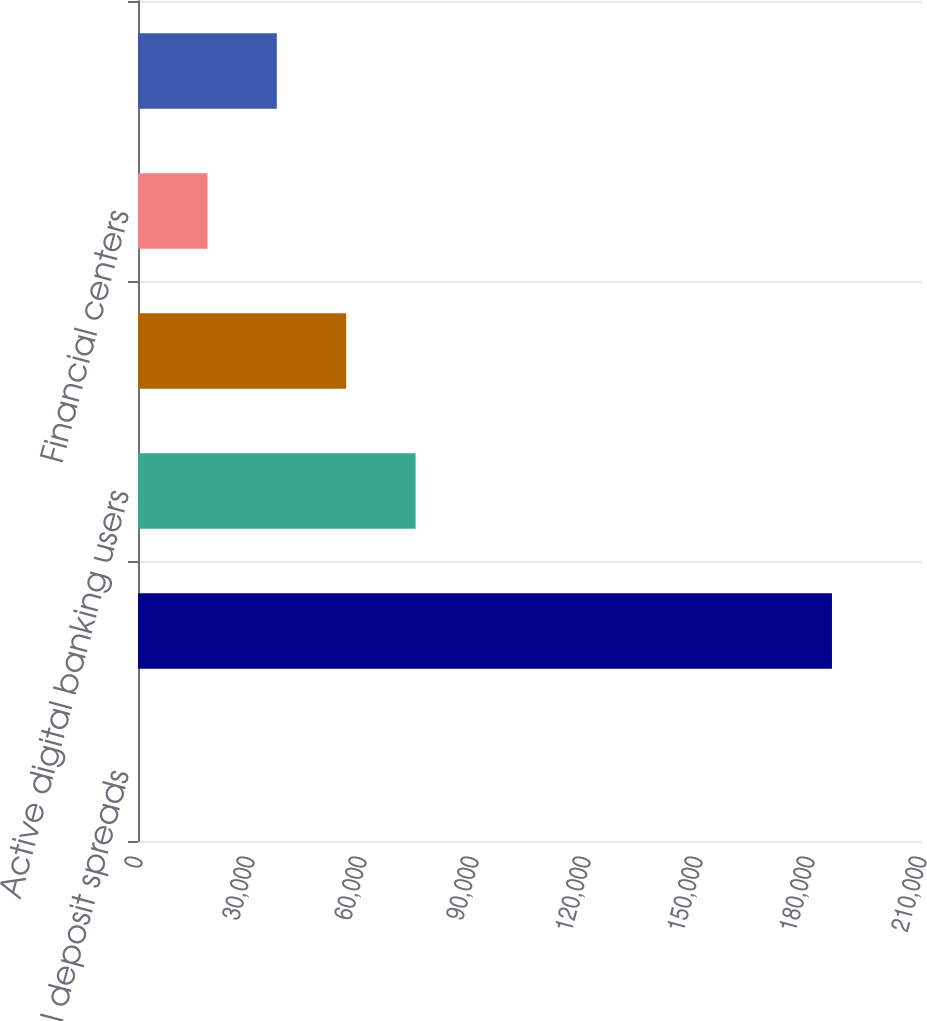<chart> <loc_0><loc_0><loc_500><loc_500><bar_chart><fcel>Total deposit spreads<fcel>Client brokerage assets (in<fcel>Active digital banking users<fcel>Active mobile banking users<fcel>Financial centers<fcel>ATMs<nl><fcel>2.14<fcel>185881<fcel>74353.7<fcel>55765.8<fcel>18590<fcel>37177.9<nl></chart> 